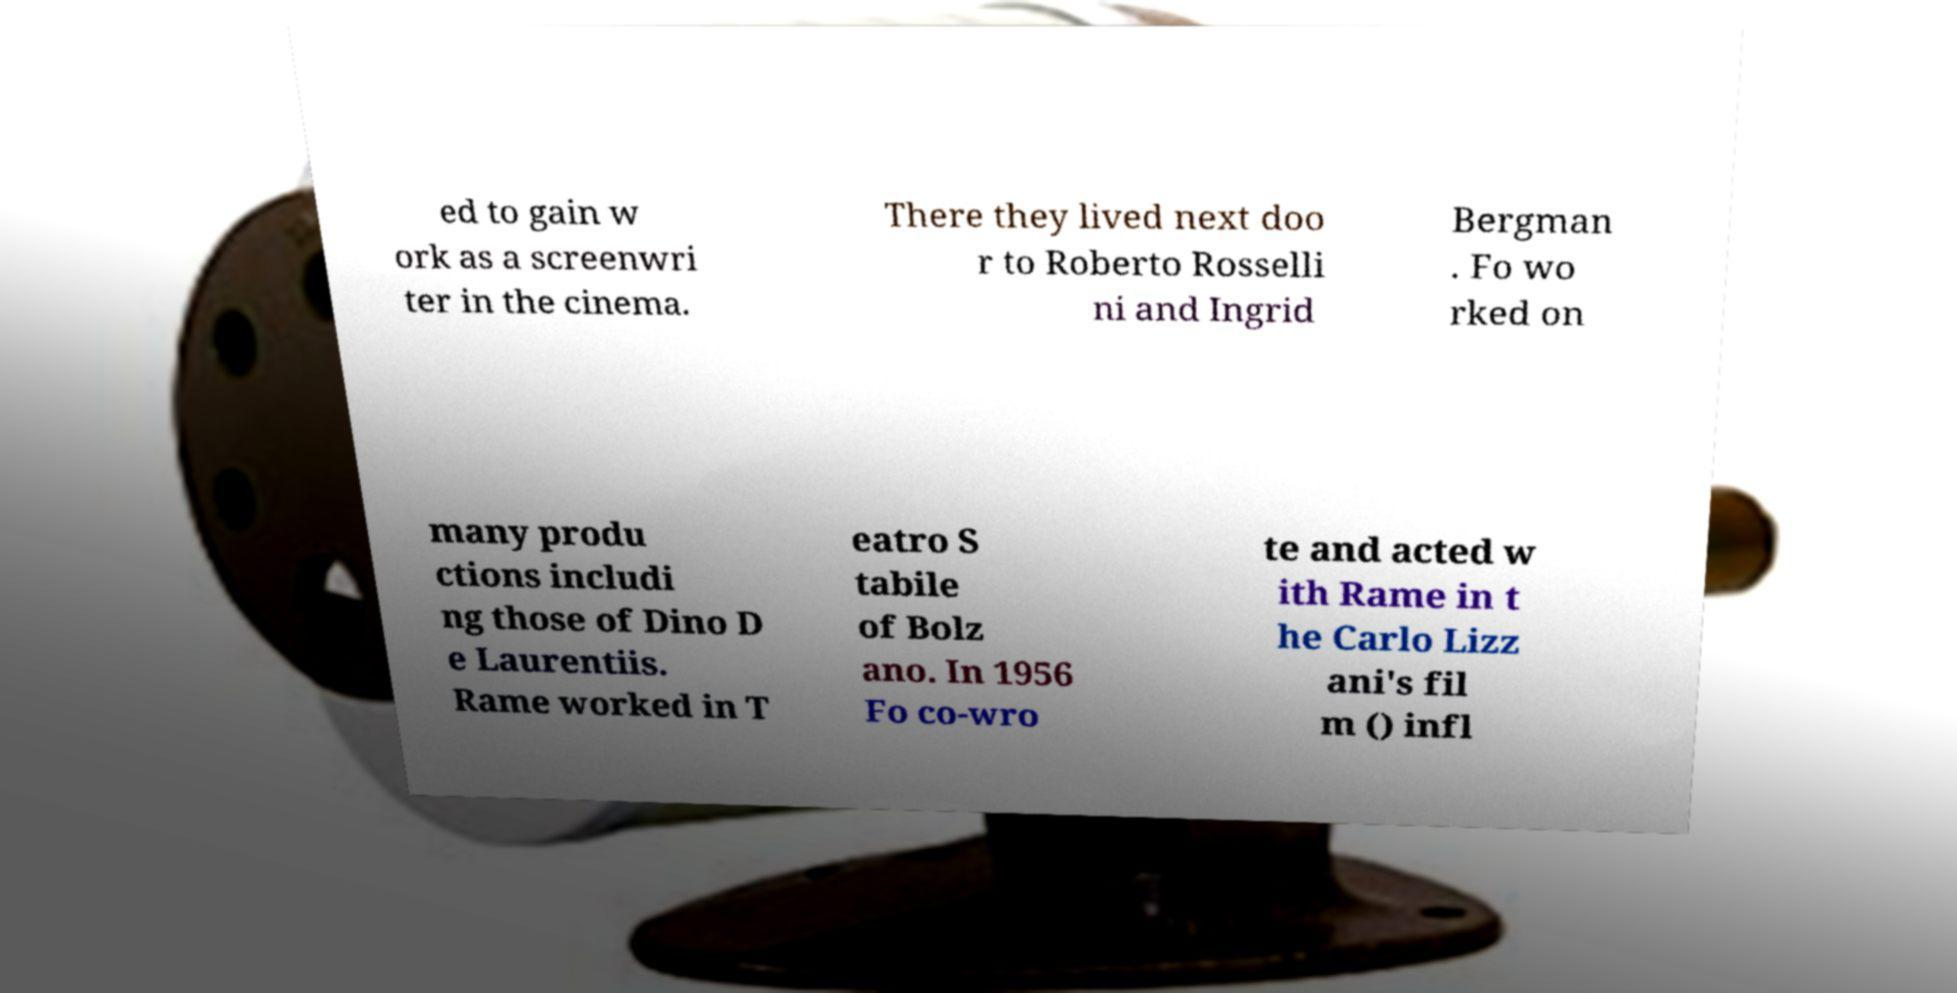What messages or text are displayed in this image? I need them in a readable, typed format. ed to gain w ork as a screenwri ter in the cinema. There they lived next doo r to Roberto Rosselli ni and Ingrid Bergman . Fo wo rked on many produ ctions includi ng those of Dino D e Laurentiis. Rame worked in T eatro S tabile of Bolz ano. In 1956 Fo co-wro te and acted w ith Rame in t he Carlo Lizz ani's fil m () infl 